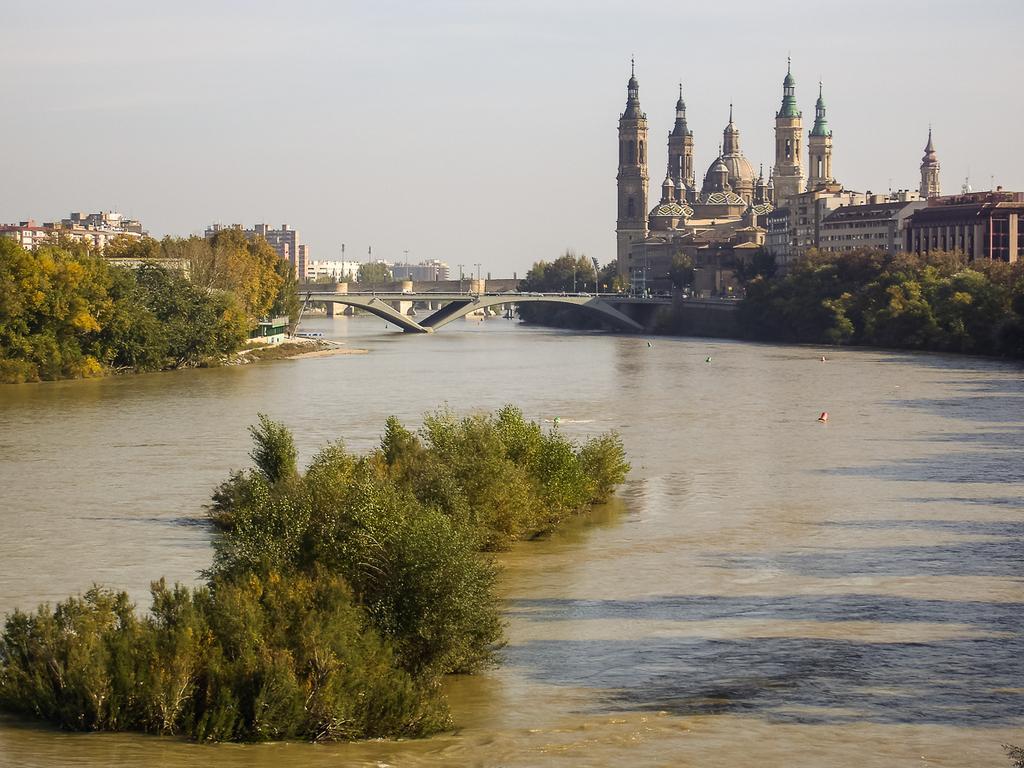Could you give a brief overview of what you see in this image? In this image I can see the trees in green color, background I can see the water, a bridge, buildings in white, cream and brown color, few poles and the sky is in white color. 